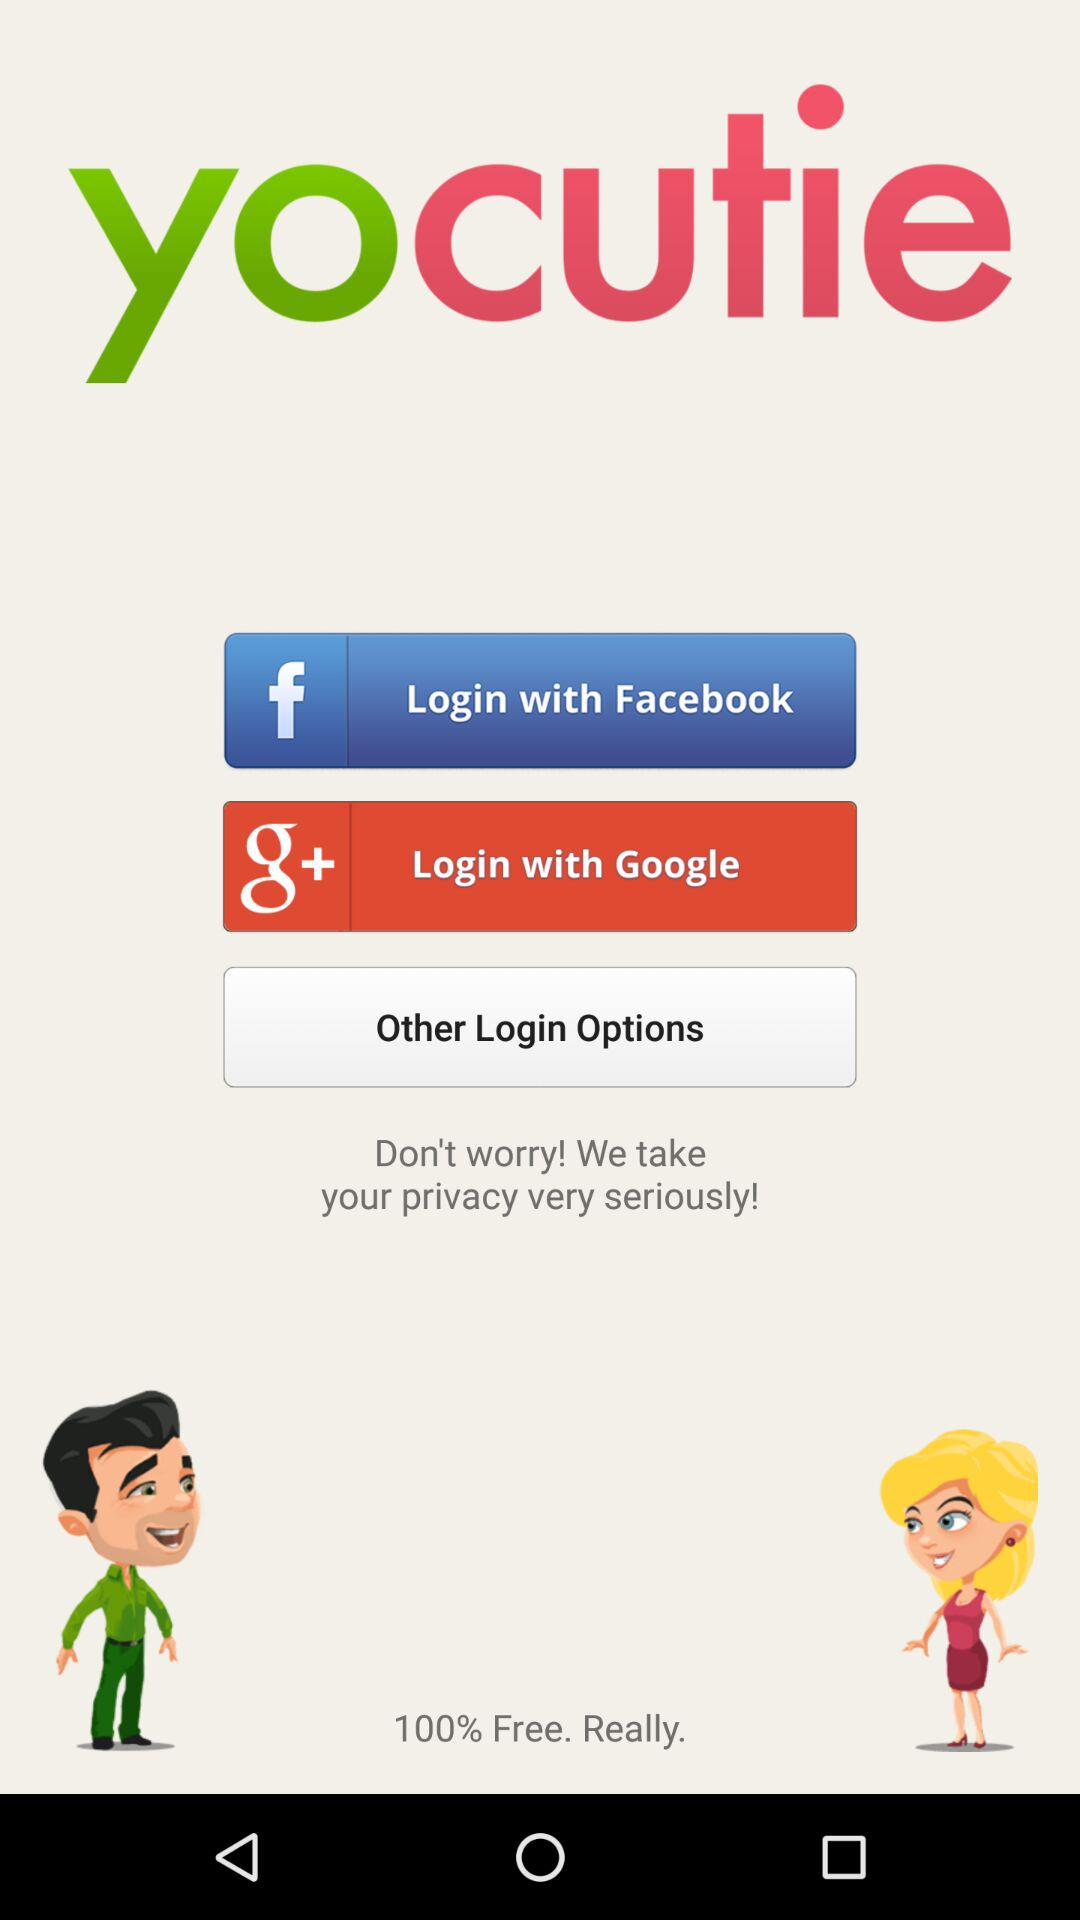How many login options are there?
Answer the question using a single word or phrase. 3 